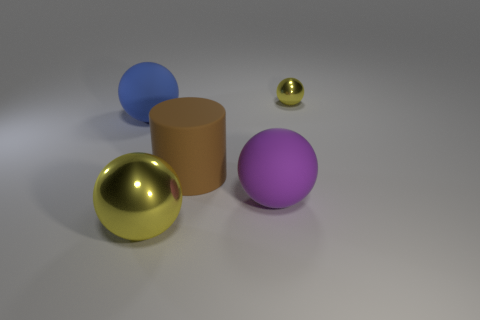Subtract 1 balls. How many balls are left? 3 Add 2 tiny spheres. How many objects exist? 7 Subtract all cylinders. How many objects are left? 4 Subtract all cyan cylinders. Subtract all big rubber spheres. How many objects are left? 3 Add 4 big yellow objects. How many big yellow objects are left? 5 Add 5 tiny shiny things. How many tiny shiny things exist? 6 Subtract 0 cyan balls. How many objects are left? 5 